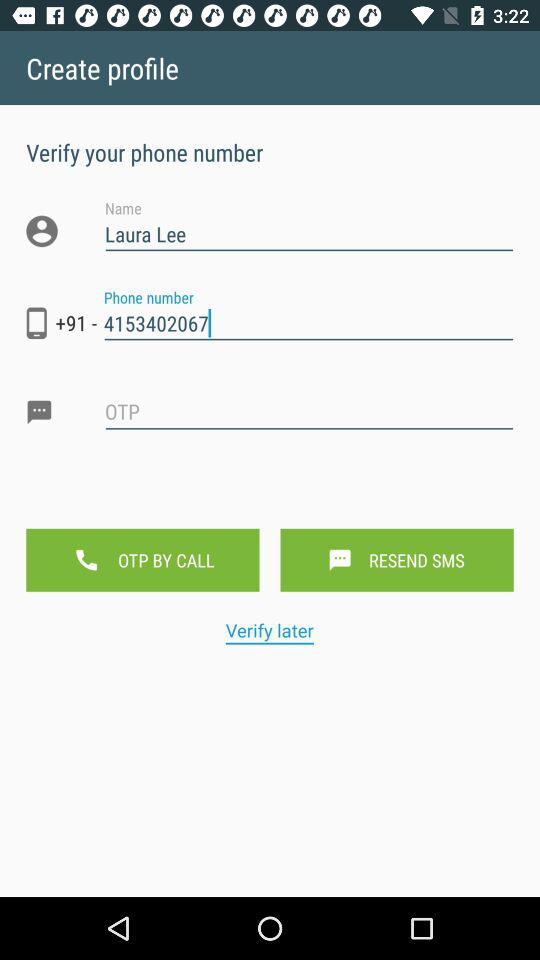How many text fields are there in the create profile page?
Answer the question using a single word or phrase. 3 